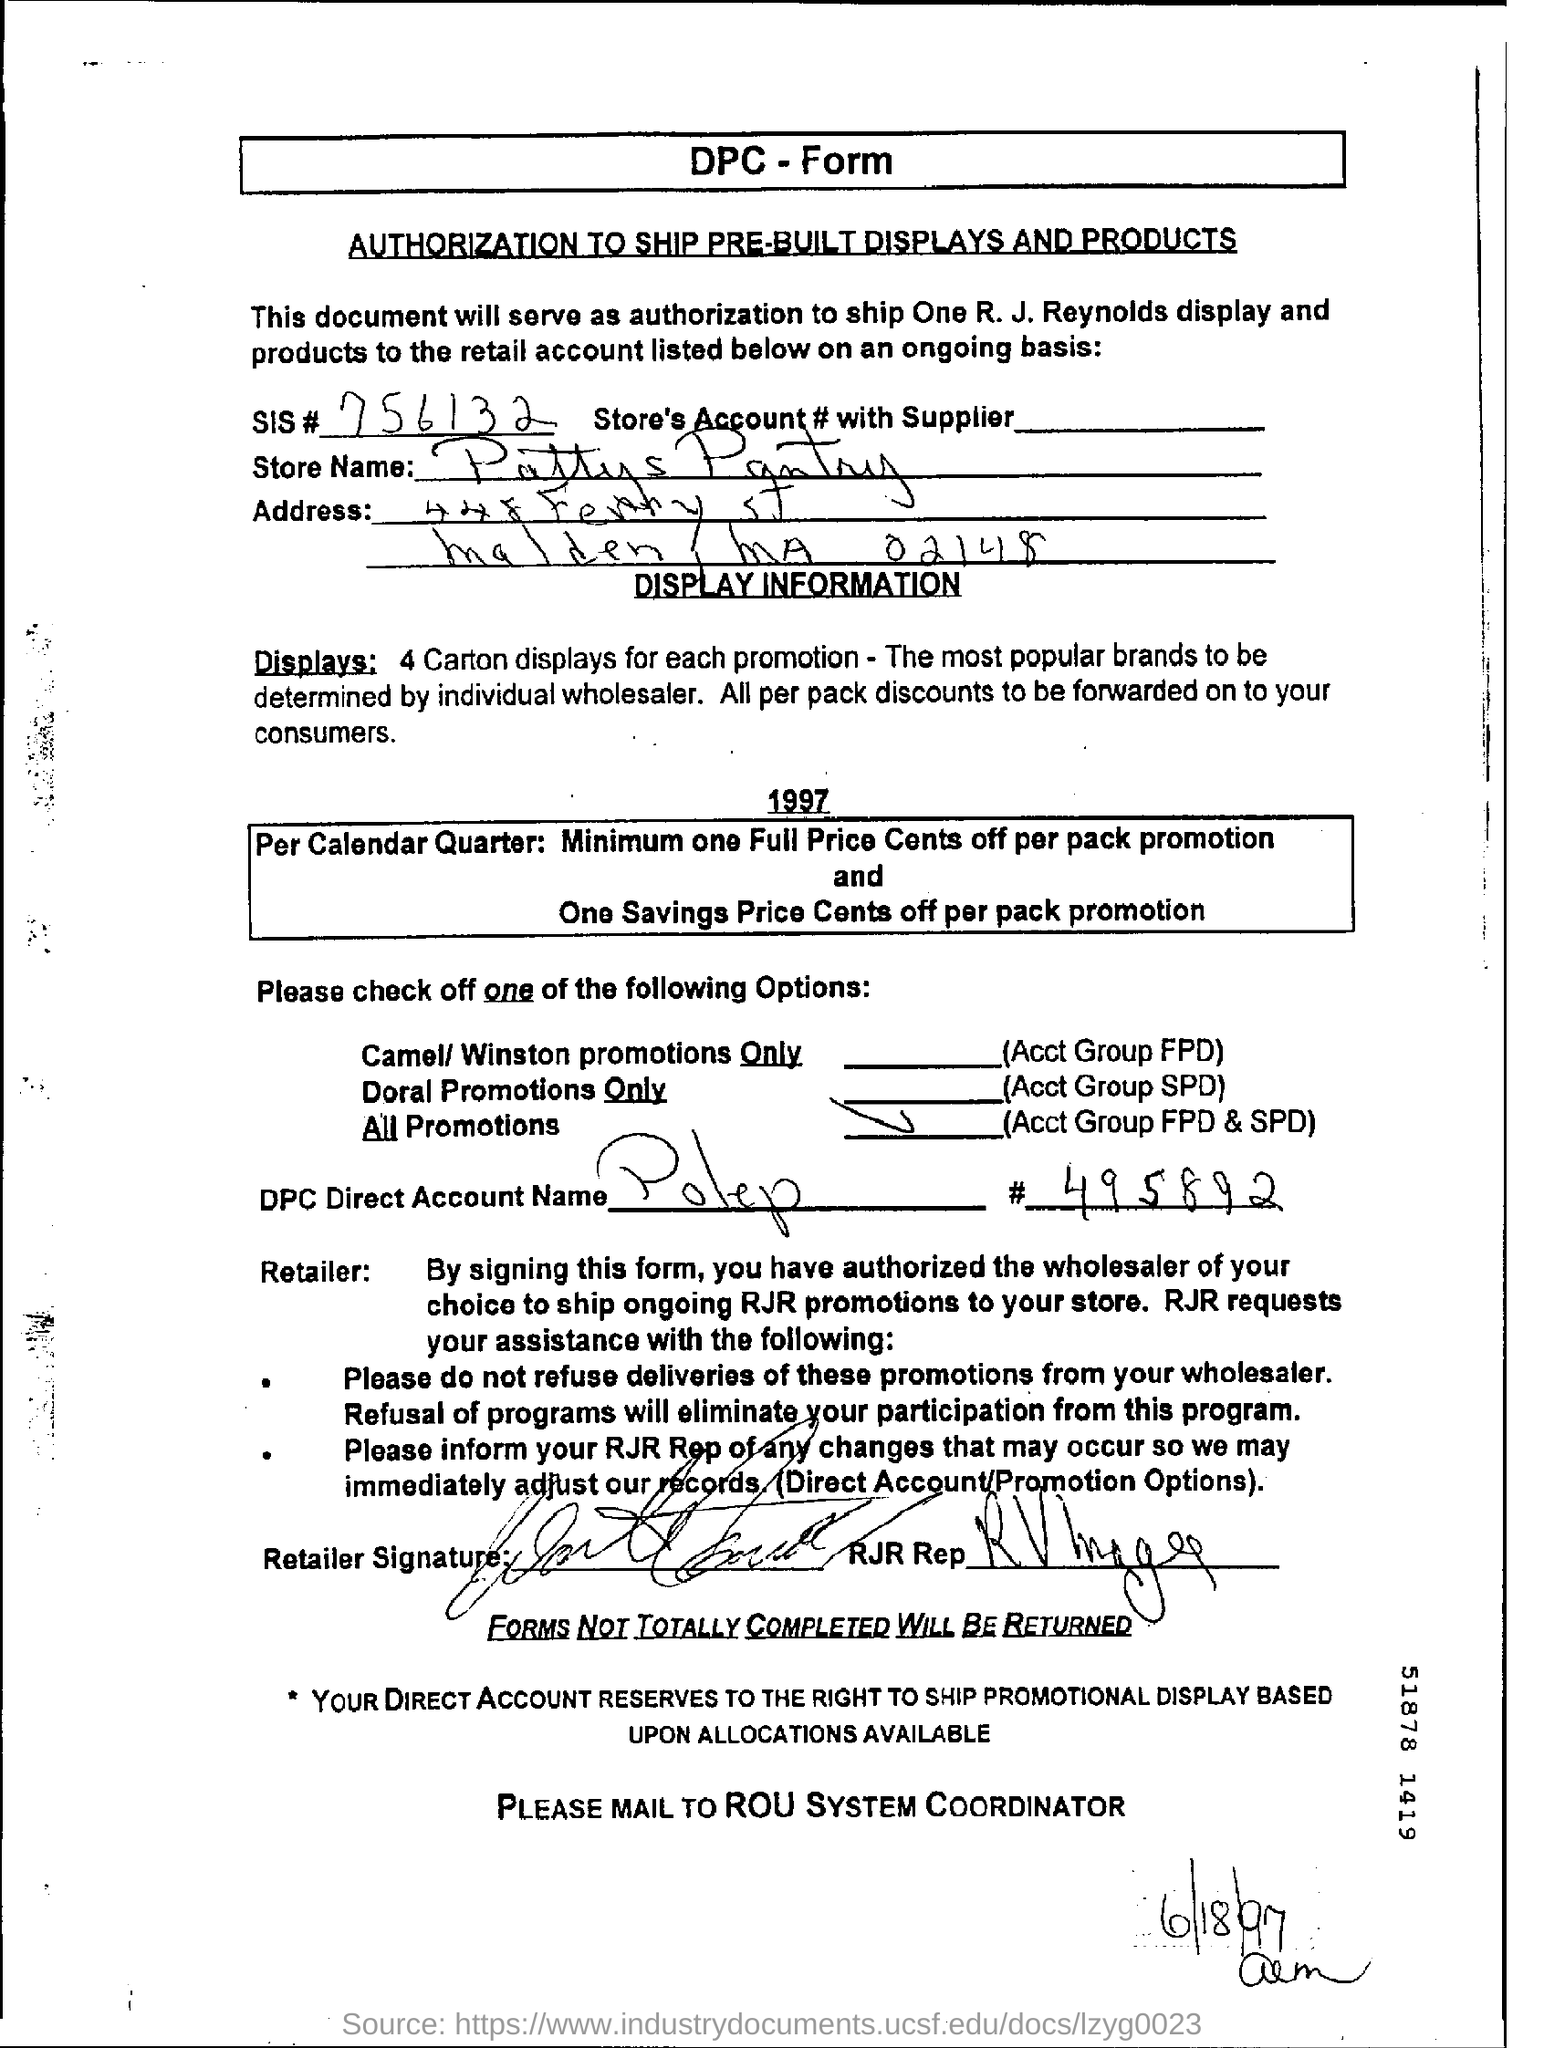Point out several critical features in this image. The SIS#, in the form 756132... , is a unique identifier for the given person. The store name given in the form is "Pattys Pantry. The date mentioned in this form is June 18, 1997. 